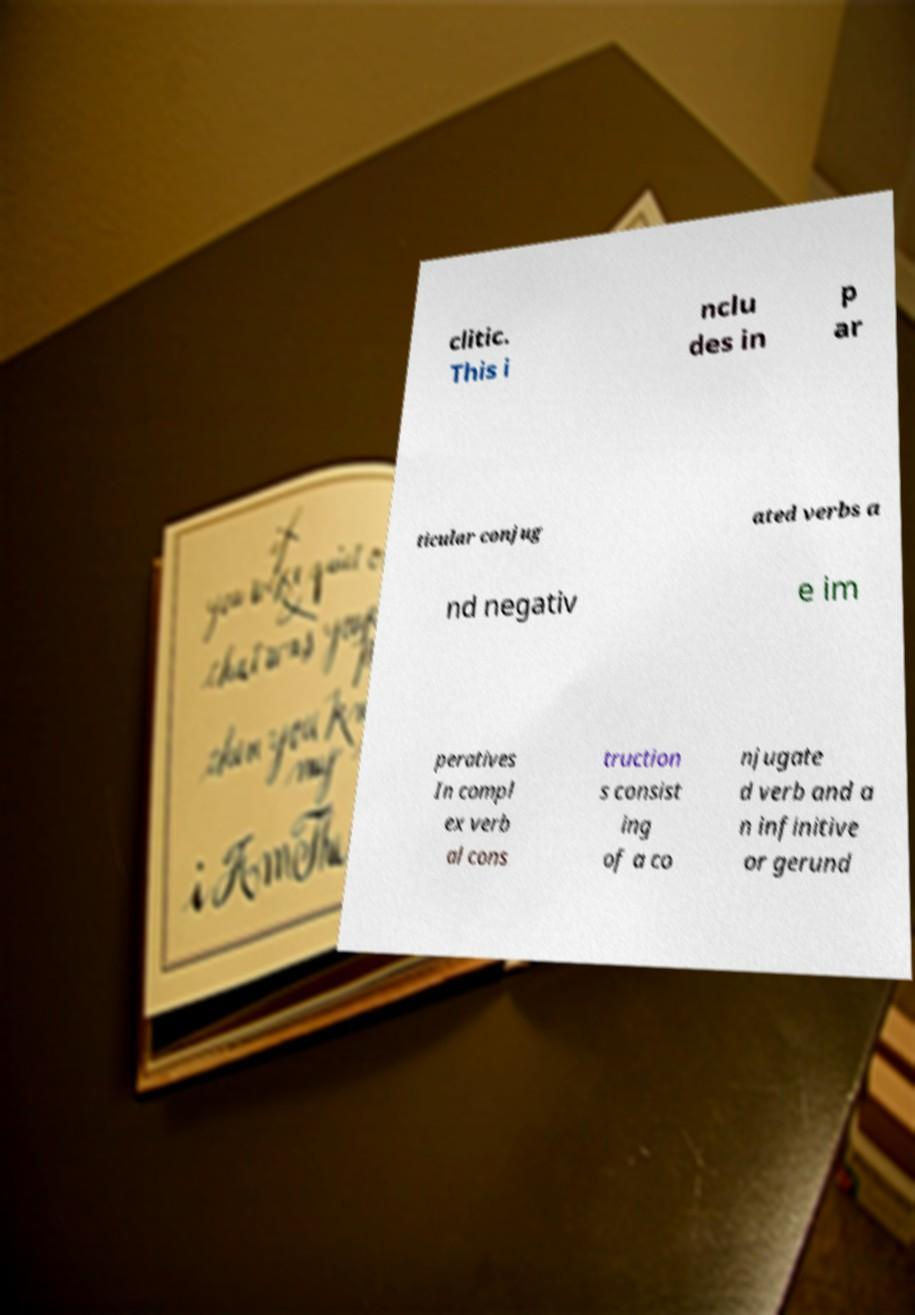Can you read and provide the text displayed in the image?This photo seems to have some interesting text. Can you extract and type it out for me? clitic. This i nclu des in p ar ticular conjug ated verbs a nd negativ e im peratives In compl ex verb al cons truction s consist ing of a co njugate d verb and a n infinitive or gerund 